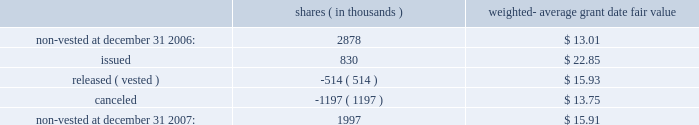Prior to its adoption of sfas no .
123 ( r ) , the company recorded compensation expense for restricted stock awards on a straight-line basis over their vesting period .
If an employee forfeited the award prior to vesting , the company reversed out the previously expensed amounts in the period of forfeiture .
As required upon adoption of sfas no .
123 ( r ) , the company must base its accruals of compensation expense on the estimated number of awards for which the requisite service period is expected to be rendered .
Actual forfeitures are no longer recorded in the period of forfeiture .
In 2005 , the company recorded a pre-tax credit of $ 2.8 million in cumulative effect of accounting change , that represents the amount by which compensation expense would have been reduced in periods prior to adoption of sfas no .
123 ( r ) for restricted stock awards outstanding on july 1 , 2005 that are anticipated to be forfeited .
A summary of non-vested restricted stock award and restricted stock unit activity is presented below : shares ( in thousands ) weighted- average date fair .
As of december 31 , 2007 , there was $ 15.3 million of total unrecognized compensation cost related to non-vested awards .
This cost is expected to be recognized over a weighted-average period of 1.6 years .
The total fair value of restricted shares and restricted stock units vested was $ 11.0 million , $ 7.5 million and $ 4.1 million for the years ended december 31 , 2007 , 2006 and 2005 , respectively .
Employee stock purchase plan the shareholders of the company previously approved the 2002 employee stock purchase plan ( 201c2002 purchase plan 201d ) , and reserved 5000000 shares of common stock for sale to employees at a price no less than 85% ( 85 % ) of the lower of the fair market value of the common stock at the beginning of the one-year offering period or the end of each of the six-month purchase periods .
Under sfas no .
123 ( r ) , the 2002 purchase plan was considered compensatory .
Effective august 1 , 2005 , the company changed the terms of its purchase plan to reduce the discount to 5% ( 5 % ) and discontinued the look-back provision .
As a result , the purchase plan was not compensatory beginning august 1 , 2005 .
For the year ended december 31 , 2005 , the company recorded $ 0.4 million in compensation expense for its employee stock purchase plan for the period in which the 2002 plan was considered compensatory until the terms were changed august 1 , 2005 .
At december 31 , 2007 , 757123 shares were available for purchase under the 2002 purchase plan .
401 ( k ) plan the company has a 401 ( k ) salary deferral program for eligible employees who have met certain service requirements .
The company matches certain employee contributions ; additional contributions to this plan are at the discretion of the company .
Total contribution expense under this plan was $ 5.7 million , $ 5.7 million and $ 5.2 million for the years ended december 31 , 2007 , 2006 and 2005 , respectively. .
What was the percentage change in total contribution expense under the plan between 2005 and 2006? 
Computations: ((5.7 - 5.2) / 5.2)
Answer: 0.09615. Prior to its adoption of sfas no .
123 ( r ) , the company recorded compensation expense for restricted stock awards on a straight-line basis over their vesting period .
If an employee forfeited the award prior to vesting , the company reversed out the previously expensed amounts in the period of forfeiture .
As required upon adoption of sfas no .
123 ( r ) , the company must base its accruals of compensation expense on the estimated number of awards for which the requisite service period is expected to be rendered .
Actual forfeitures are no longer recorded in the period of forfeiture .
In 2005 , the company recorded a pre-tax credit of $ 2.8 million in cumulative effect of accounting change , that represents the amount by which compensation expense would have been reduced in periods prior to adoption of sfas no .
123 ( r ) for restricted stock awards outstanding on july 1 , 2005 that are anticipated to be forfeited .
A summary of non-vested restricted stock award and restricted stock unit activity is presented below : shares ( in thousands ) weighted- average date fair .
As of december 31 , 2007 , there was $ 15.3 million of total unrecognized compensation cost related to non-vested awards .
This cost is expected to be recognized over a weighted-average period of 1.6 years .
The total fair value of restricted shares and restricted stock units vested was $ 11.0 million , $ 7.5 million and $ 4.1 million for the years ended december 31 , 2007 , 2006 and 2005 , respectively .
Employee stock purchase plan the shareholders of the company previously approved the 2002 employee stock purchase plan ( 201c2002 purchase plan 201d ) , and reserved 5000000 shares of common stock for sale to employees at a price no less than 85% ( 85 % ) of the lower of the fair market value of the common stock at the beginning of the one-year offering period or the end of each of the six-month purchase periods .
Under sfas no .
123 ( r ) , the 2002 purchase plan was considered compensatory .
Effective august 1 , 2005 , the company changed the terms of its purchase plan to reduce the discount to 5% ( 5 % ) and discontinued the look-back provision .
As a result , the purchase plan was not compensatory beginning august 1 , 2005 .
For the year ended december 31 , 2005 , the company recorded $ 0.4 million in compensation expense for its employee stock purchase plan for the period in which the 2002 plan was considered compensatory until the terms were changed august 1 , 2005 .
At december 31 , 2007 , 757123 shares were available for purchase under the 2002 purchase plan .
401 ( k ) plan the company has a 401 ( k ) salary deferral program for eligible employees who have met certain service requirements .
The company matches certain employee contributions ; additional contributions to this plan are at the discretion of the company .
Total contribution expense under this plan was $ 5.7 million , $ 5.7 million and $ 5.2 million for the years ended december 31 , 2007 , 2006 and 2005 , respectively. .
What was the percentage change in total contribution expense under the plan between 2006 and 2007? 
Computations: ((5.7 - 5.7) / 5.7)
Answer: 0.0. Prior to its adoption of sfas no .
123 ( r ) , the company recorded compensation expense for restricted stock awards on a straight-line basis over their vesting period .
If an employee forfeited the award prior to vesting , the company reversed out the previously expensed amounts in the period of forfeiture .
As required upon adoption of sfas no .
123 ( r ) , the company must base its accruals of compensation expense on the estimated number of awards for which the requisite service period is expected to be rendered .
Actual forfeitures are no longer recorded in the period of forfeiture .
In 2005 , the company recorded a pre-tax credit of $ 2.8 million in cumulative effect of accounting change , that represents the amount by which compensation expense would have been reduced in periods prior to adoption of sfas no .
123 ( r ) for restricted stock awards outstanding on july 1 , 2005 that are anticipated to be forfeited .
A summary of non-vested restricted stock award and restricted stock unit activity is presented below : shares ( in thousands ) weighted- average date fair .
As of december 31 , 2007 , there was $ 15.3 million of total unrecognized compensation cost related to non-vested awards .
This cost is expected to be recognized over a weighted-average period of 1.6 years .
The total fair value of restricted shares and restricted stock units vested was $ 11.0 million , $ 7.5 million and $ 4.1 million for the years ended december 31 , 2007 , 2006 and 2005 , respectively .
Employee stock purchase plan the shareholders of the company previously approved the 2002 employee stock purchase plan ( 201c2002 purchase plan 201d ) , and reserved 5000000 shares of common stock for sale to employees at a price no less than 85% ( 85 % ) of the lower of the fair market value of the common stock at the beginning of the one-year offering period or the end of each of the six-month purchase periods .
Under sfas no .
123 ( r ) , the 2002 purchase plan was considered compensatory .
Effective august 1 , 2005 , the company changed the terms of its purchase plan to reduce the discount to 5% ( 5 % ) and discontinued the look-back provision .
As a result , the purchase plan was not compensatory beginning august 1 , 2005 .
For the year ended december 31 , 2005 , the company recorded $ 0.4 million in compensation expense for its employee stock purchase plan for the period in which the 2002 plan was considered compensatory until the terms were changed august 1 , 2005 .
At december 31 , 2007 , 757123 shares were available for purchase under the 2002 purchase plan .
401 ( k ) plan the company has a 401 ( k ) salary deferral program for eligible employees who have met certain service requirements .
The company matches certain employee contributions ; additional contributions to this plan are at the discretion of the company .
Total contribution expense under this plan was $ 5.7 million , $ 5.7 million and $ 5.2 million for the years ended december 31 , 2007 , 2006 and 2005 , respectively. .
What was the ratio of the total fair value of restricted shares and restricted stock units vested in 2007 to 2006? 
Rationale: total fair value of restricted shares and restricted stock units vested in 2007 to 2006 was 1.47 to 1
Computations: (11.0 / 7.5)
Answer: 1.46667. 